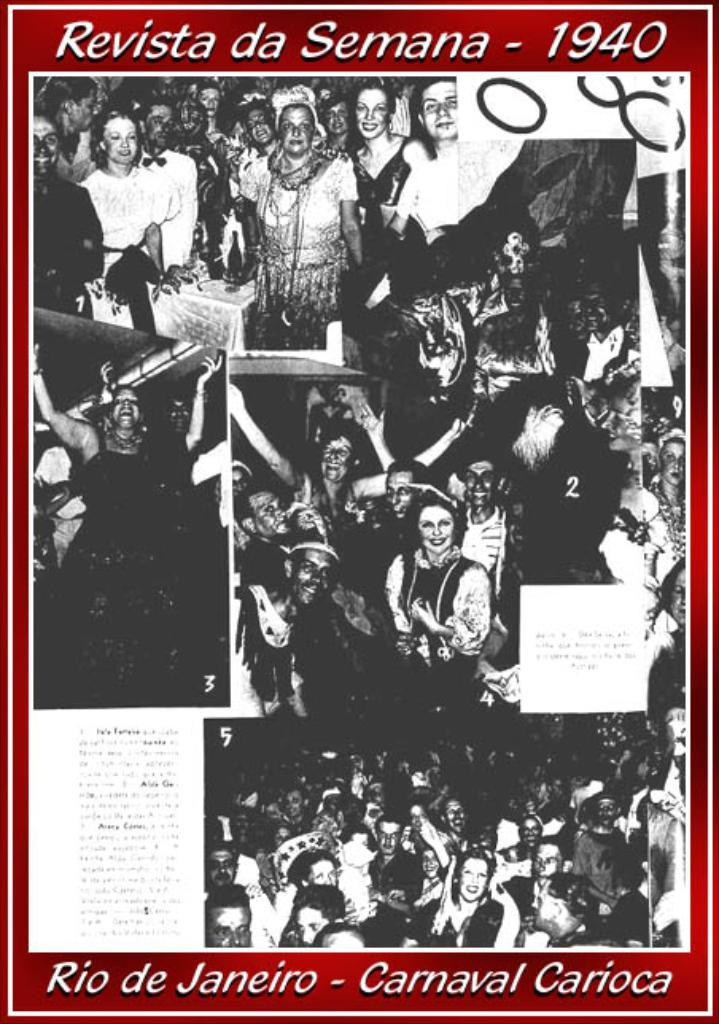What type of visual representation is shown in the image? The image is a poster. What is happening in the scene depicted on the poster? There is a crowd depicted on the poster. Are there any words or phrases on the poster? Yes, there is text written on the poster. Can you see any chess pieces being played on the poster? There are no chess pieces or a game of chess depicted on the poster. Is there a cable visible in the image? There is no cable present in the image. 